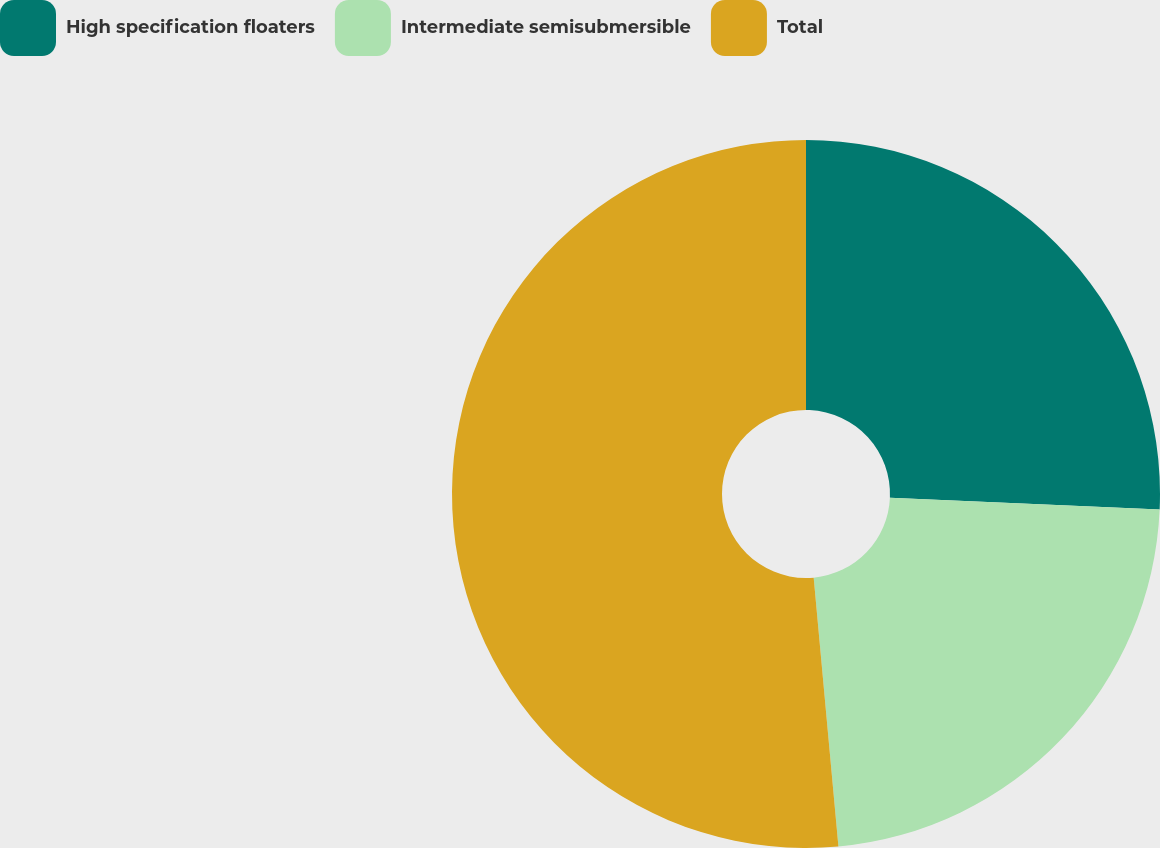Convert chart. <chart><loc_0><loc_0><loc_500><loc_500><pie_chart><fcel>High specification floaters<fcel>Intermediate semisubmersible<fcel>Total<nl><fcel>25.7%<fcel>22.84%<fcel>51.46%<nl></chart> 